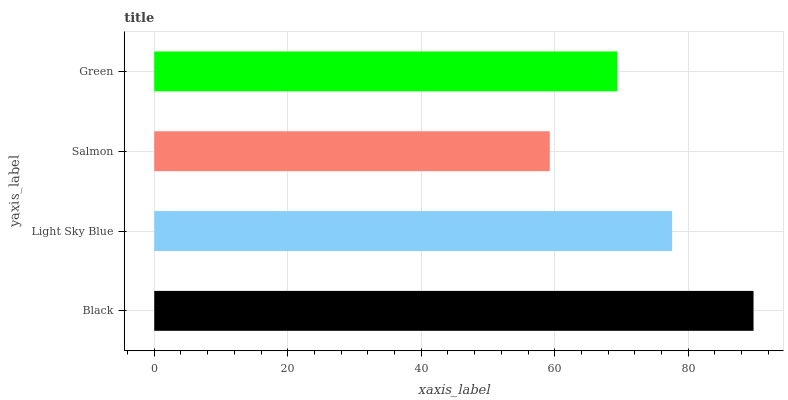Is Salmon the minimum?
Answer yes or no. Yes. Is Black the maximum?
Answer yes or no. Yes. Is Light Sky Blue the minimum?
Answer yes or no. No. Is Light Sky Blue the maximum?
Answer yes or no. No. Is Black greater than Light Sky Blue?
Answer yes or no. Yes. Is Light Sky Blue less than Black?
Answer yes or no. Yes. Is Light Sky Blue greater than Black?
Answer yes or no. No. Is Black less than Light Sky Blue?
Answer yes or no. No. Is Light Sky Blue the high median?
Answer yes or no. Yes. Is Green the low median?
Answer yes or no. Yes. Is Salmon the high median?
Answer yes or no. No. Is Black the low median?
Answer yes or no. No. 